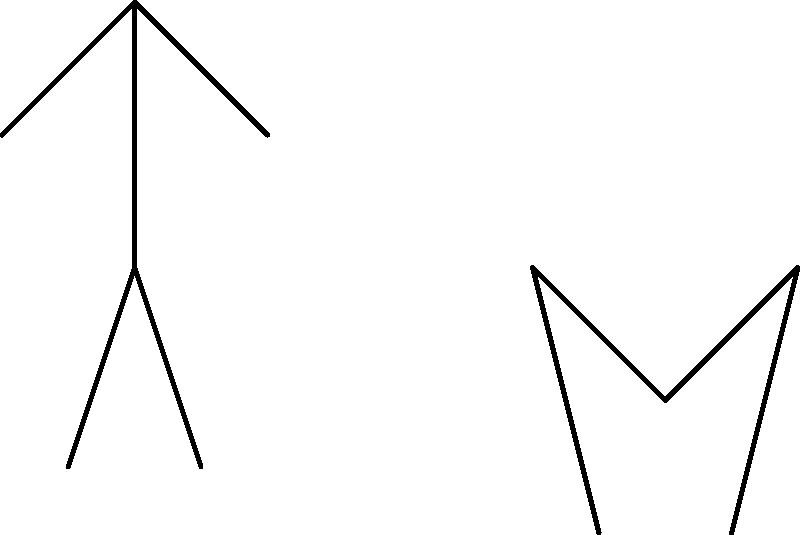In a rugby tackle, Player A (left) exerts a force $\vec{F}_A$ on Player B (right) at an angle $\theta_A = 18°$ below the horizontal. Player B counters with a force $\vec{F}_B$ at an angle $\theta_B = 30°$ above the horizontal. If $|\vec{F}_A| = 800$ N and $|\vec{F}_B| = 600$ N, calculate the net horizontal force acting on the system formed by both players. To solve this problem, we need to follow these steps:

1. Decompose both forces into their horizontal components:

   For $\vec{F}_A$: 
   $F_{Ax} = |\vec{F}_A| \cos(\theta_A) = 800 \cos(18°) = 760.85$ N (positive direction)

   For $\vec{F}_B$:
   $F_{Bx} = |\vec{F}_B| \cos(\theta_B) = 600 \cos(30°) = 519.62$ N (negative direction)

2. Calculate the net horizontal force by adding these components:

   $F_{net,x} = F_{Ax} - F_{Bx}$ (subtracting because $\vec{F}_B$ is in the opposite direction)
   
   $F_{net,x} = 760.85 - 519.62 = 241.23$ N

3. The net horizontal force is 241.23 N in the positive x-direction (towards the right in the diagram).

This result indicates that Player A is exerting a greater horizontal force, which could potentially drive Player B backwards if other factors remain constant.
Answer: 241.23 N to the right 